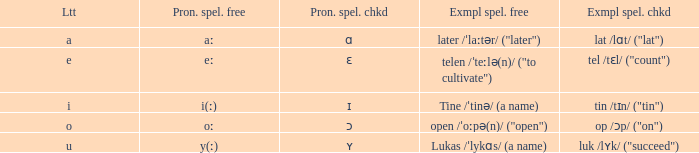What is Pronunciation Spelled Checked, when Example Spelled Checked is "tin /tɪn/ ("tin")" Ɪ. 